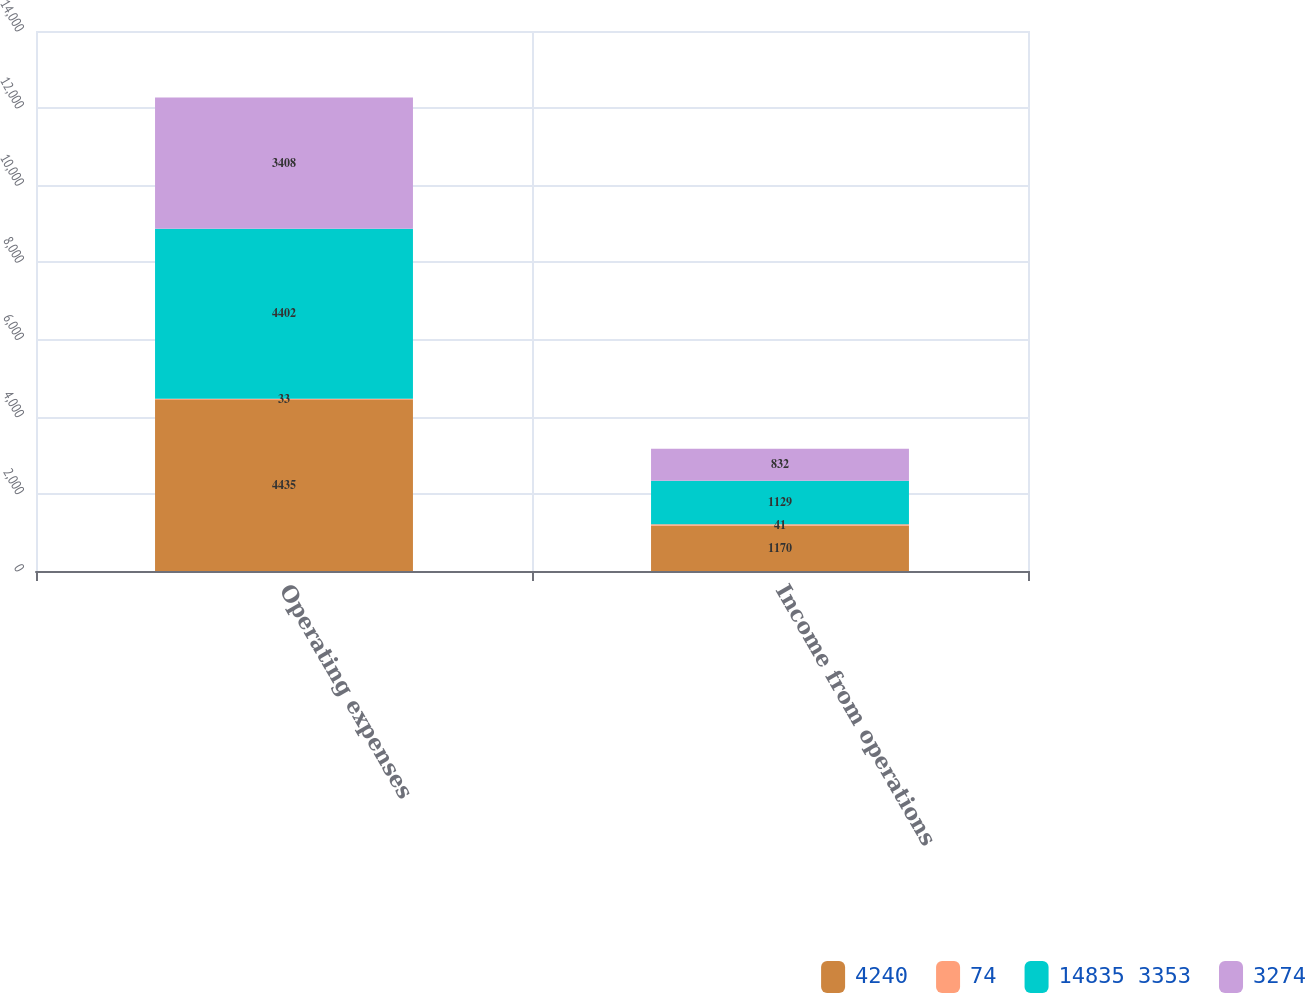Convert chart. <chart><loc_0><loc_0><loc_500><loc_500><stacked_bar_chart><ecel><fcel>Operating expenses<fcel>Income from operations<nl><fcel>4240<fcel>4435<fcel>1170<nl><fcel>74<fcel>33<fcel>41<nl><fcel>14835 3353<fcel>4402<fcel>1129<nl><fcel>3274<fcel>3408<fcel>832<nl></chart> 